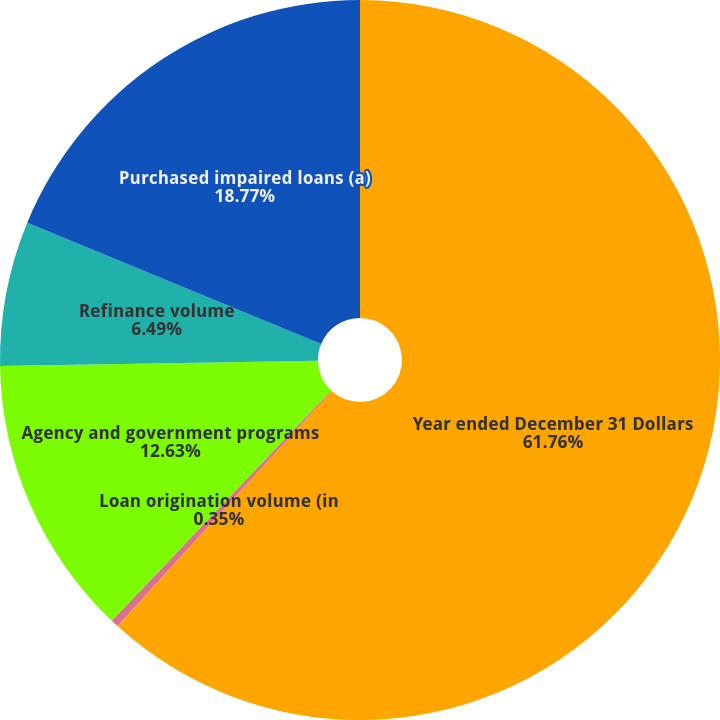Convert chart to OTSL. <chart><loc_0><loc_0><loc_500><loc_500><pie_chart><fcel>Year ended December 31 Dollars<fcel>Loan origination volume (in<fcel>Agency and government programs<fcel>Refinance volume<fcel>Purchased impaired loans (a)<nl><fcel>61.76%<fcel>0.35%<fcel>12.63%<fcel>6.49%<fcel>18.77%<nl></chart> 